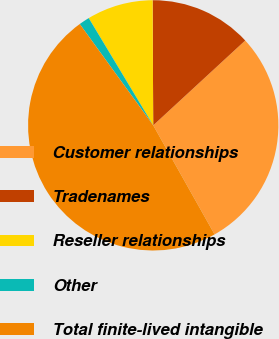<chart> <loc_0><loc_0><loc_500><loc_500><pie_chart><fcel>Customer relationships<fcel>Tradenames<fcel>Reseller relationships<fcel>Other<fcel>Total finite-lived intangible<nl><fcel>28.7%<fcel>13.22%<fcel>8.54%<fcel>1.37%<fcel>48.17%<nl></chart> 